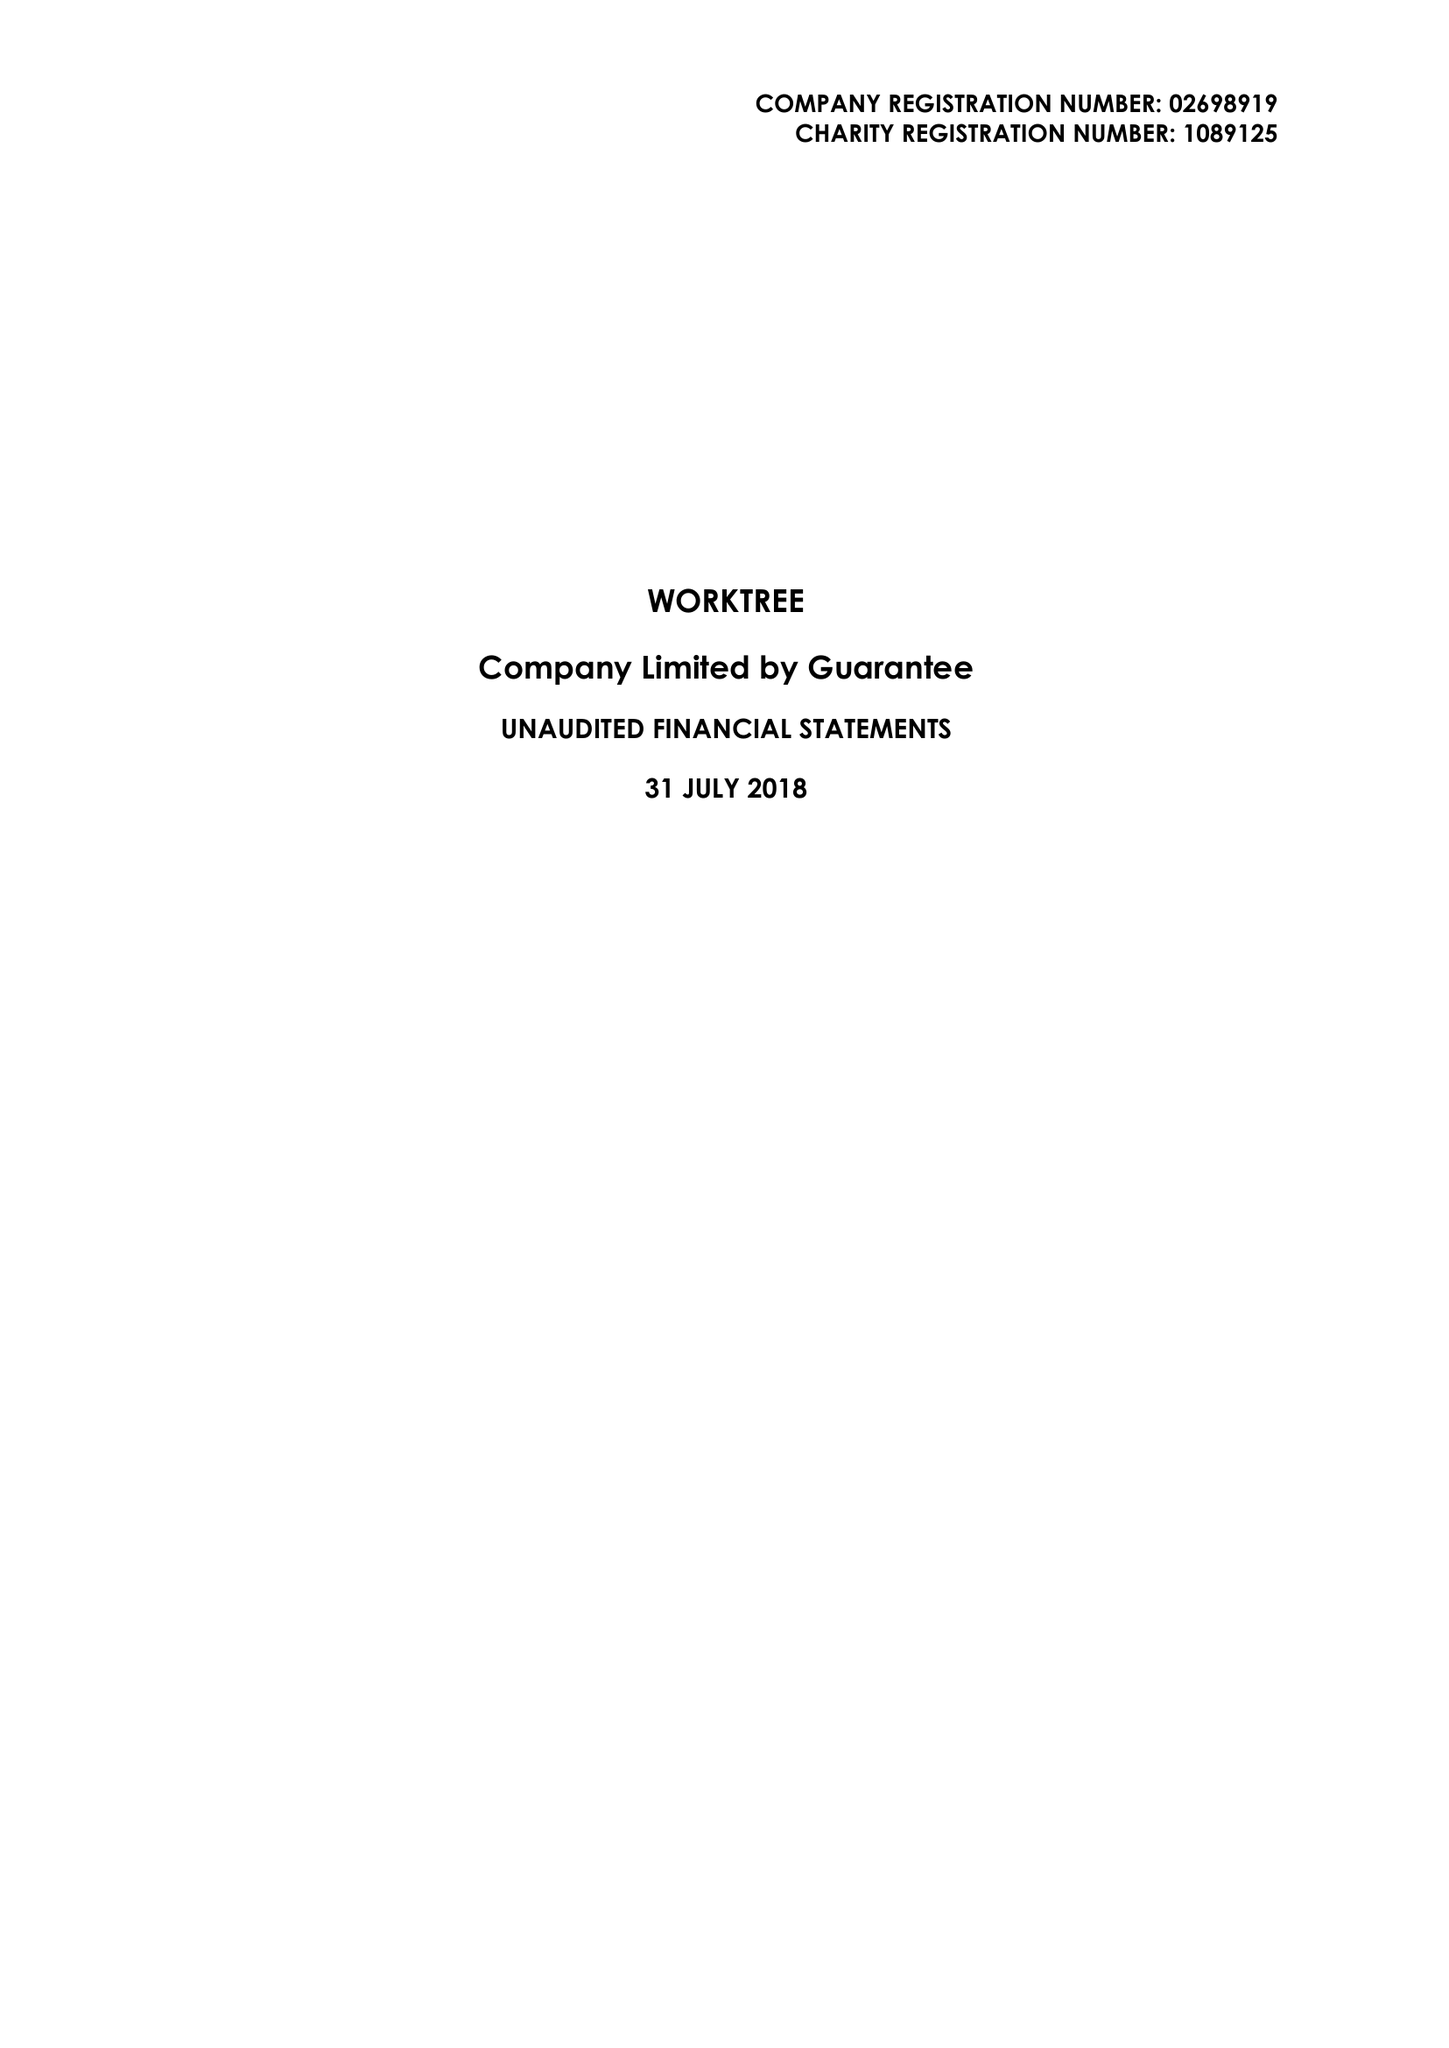What is the value for the income_annually_in_british_pounds?
Answer the question using a single word or phrase. 89184.00 